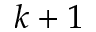Convert formula to latex. <formula><loc_0><loc_0><loc_500><loc_500>k + 1</formula> 